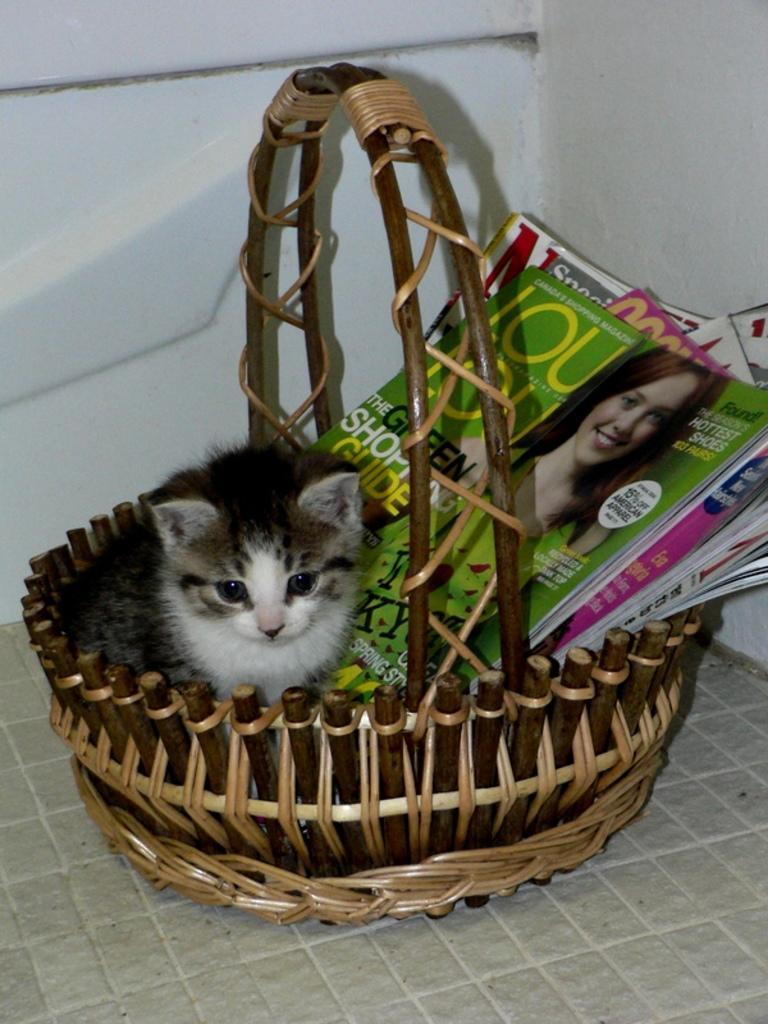Please provide a concise description of this image. In this picture we can see a basket with a cat, books in it and this basket is placed on the floor and in the background we can see the walls. 